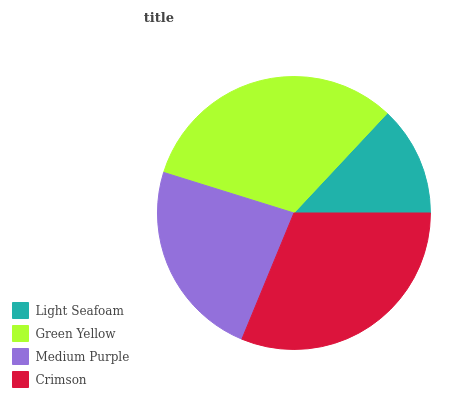Is Light Seafoam the minimum?
Answer yes or no. Yes. Is Green Yellow the maximum?
Answer yes or no. Yes. Is Medium Purple the minimum?
Answer yes or no. No. Is Medium Purple the maximum?
Answer yes or no. No. Is Green Yellow greater than Medium Purple?
Answer yes or no. Yes. Is Medium Purple less than Green Yellow?
Answer yes or no. Yes. Is Medium Purple greater than Green Yellow?
Answer yes or no. No. Is Green Yellow less than Medium Purple?
Answer yes or no. No. Is Crimson the high median?
Answer yes or no. Yes. Is Medium Purple the low median?
Answer yes or no. Yes. Is Medium Purple the high median?
Answer yes or no. No. Is Green Yellow the low median?
Answer yes or no. No. 